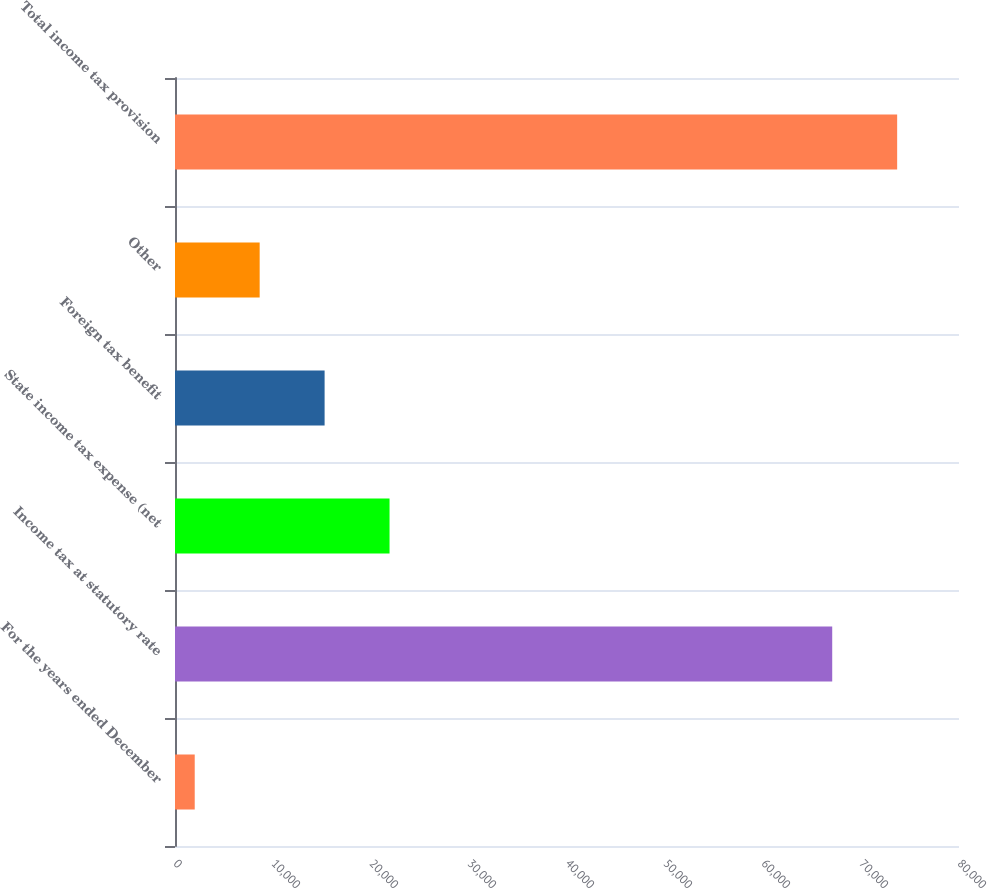Convert chart. <chart><loc_0><loc_0><loc_500><loc_500><bar_chart><fcel>For the years ended December<fcel>Income tax at statutory rate<fcel>State income tax expense (net<fcel>Foreign tax benefit<fcel>Other<fcel>Total income tax provision<nl><fcel>2013<fcel>67063<fcel>21891.9<fcel>15265.6<fcel>8639.3<fcel>73689.3<nl></chart> 